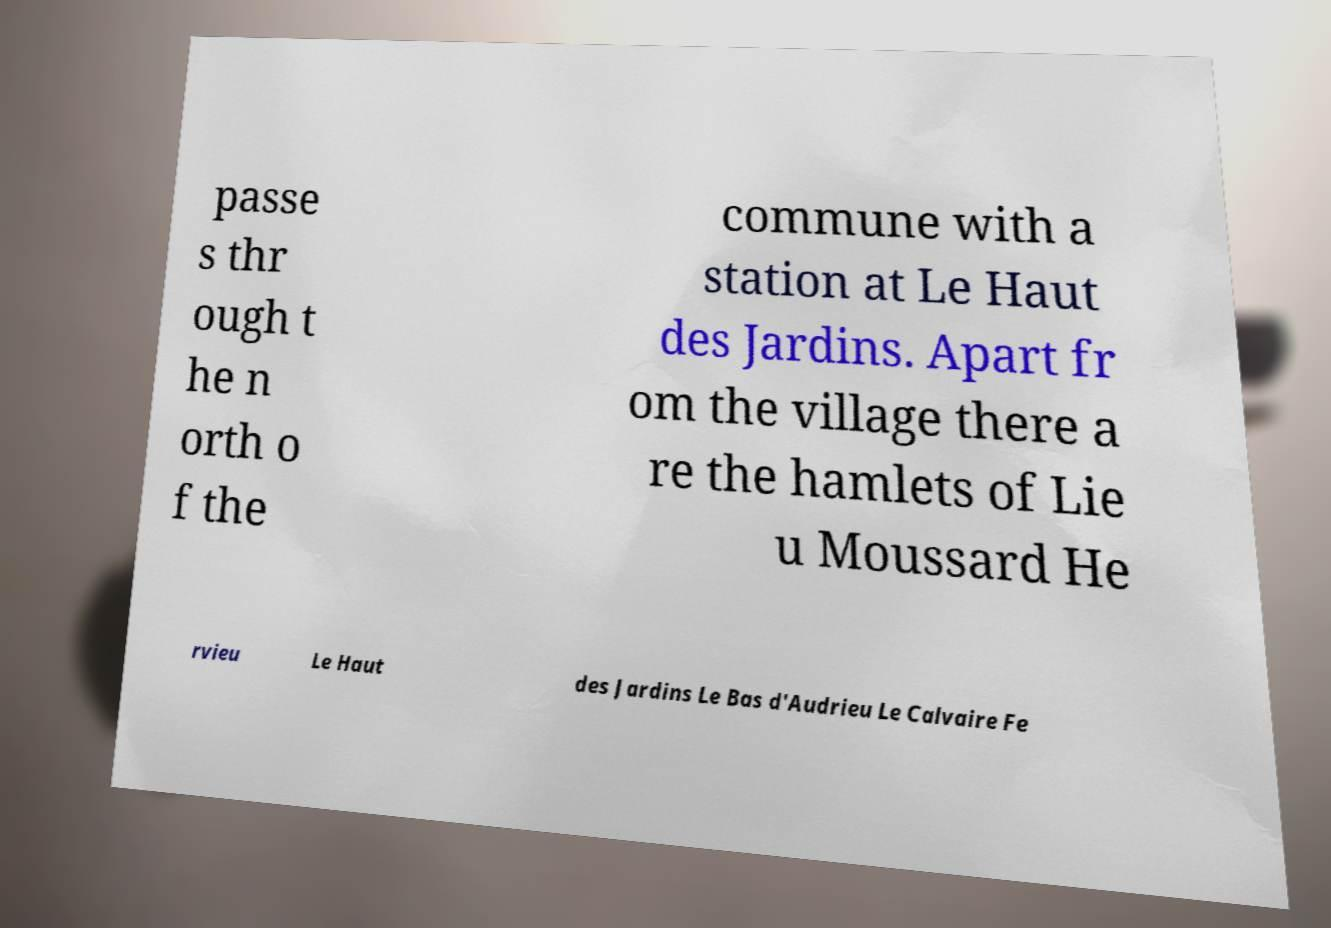Can you read and provide the text displayed in the image?This photo seems to have some interesting text. Can you extract and type it out for me? passe s thr ough t he n orth o f the commune with a station at Le Haut des Jardins. Apart fr om the village there a re the hamlets of Lie u Moussard He rvieu Le Haut des Jardins Le Bas d'Audrieu Le Calvaire Fe 